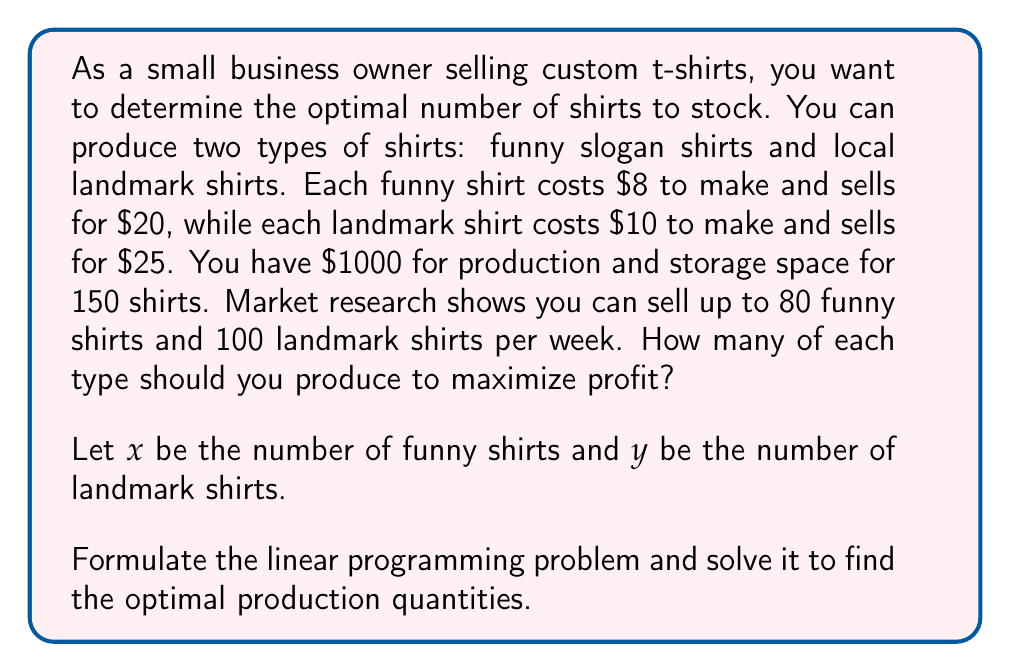Can you solve this math problem? Let's approach this step-by-step:

1. Define the objective function:
   Profit = (Selling price - Cost) × Quantity
   For funny shirts: $(20 - 8)x = 12x$
   For landmark shirts: $(25 - 10)y = 15y$
   Total profit: $Z = 12x + 15y$

2. Identify constraints:
   a. Budget: $8x + 10y \leq 1000$
   b. Storage: $x + y \leq 150$
   c. Market demand: $x \leq 80$ and $y \leq 100$
   d. Non-negativity: $x \geq 0$ and $y \geq 0$

3. Formulate the linear programming problem:
   Maximize $Z = 12x + 15y$
   Subject to:
   $$\begin{align*}
   8x + 10y &\leq 1000 \\
   x + y &\leq 150 \\
   x &\leq 80 \\
   y &\leq 100 \\
   x, y &\geq 0
   \end{align*}$$

4. Solve using the graphical method:
   Plot the constraints and identify the feasible region.

5. Find the corner points of the feasible region:
   (0, 0), (80, 0), (80, 70), (50, 100), (0, 100)

6. Evaluate the objective function at each corner point:
   $Z(0, 0) = 0$
   $Z(80, 0) = 960$
   $Z(80, 70) = 2010$
   $Z(50, 100) = 2100$
   $Z(0, 100) = 1500$

7. The maximum profit occurs at (50, 100), which satisfies all constraints.

Therefore, the optimal production quantities are 50 funny shirts and 100 landmark shirts.
Answer: 50 funny shirts, 100 landmark shirts 